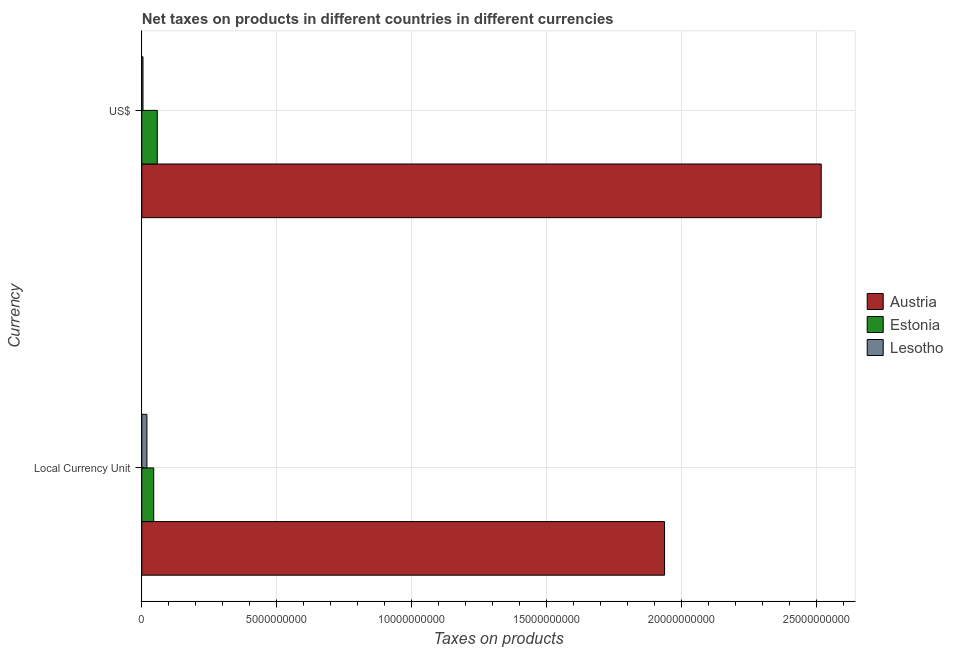How many different coloured bars are there?
Keep it short and to the point. 3. How many groups of bars are there?
Give a very brief answer. 2. Are the number of bars per tick equal to the number of legend labels?
Make the answer very short. Yes. Are the number of bars on each tick of the Y-axis equal?
Your answer should be very brief. Yes. How many bars are there on the 2nd tick from the top?
Make the answer very short. 3. How many bars are there on the 1st tick from the bottom?
Your answer should be compact. 3. What is the label of the 1st group of bars from the top?
Provide a succinct answer. US$. What is the net taxes in constant 2005 us$ in Estonia?
Offer a very short reply. 4.41e+08. Across all countries, what is the maximum net taxes in us$?
Your response must be concise. 2.52e+1. Across all countries, what is the minimum net taxes in constant 2005 us$?
Keep it short and to the point. 1.90e+08. In which country was the net taxes in us$ minimum?
Your answer should be very brief. Lesotho. What is the total net taxes in us$ in the graph?
Ensure brevity in your answer.  2.58e+1. What is the difference between the net taxes in constant 2005 us$ in Austria and that in Lesotho?
Provide a succinct answer. 1.92e+1. What is the difference between the net taxes in constant 2005 us$ in Austria and the net taxes in us$ in Lesotho?
Your answer should be very brief. 1.93e+1. What is the average net taxes in constant 2005 us$ per country?
Offer a very short reply. 6.66e+09. What is the difference between the net taxes in us$ and net taxes in constant 2005 us$ in Estonia?
Your answer should be compact. 1.33e+08. In how many countries, is the net taxes in us$ greater than 17000000000 units?
Give a very brief answer. 1. What is the ratio of the net taxes in us$ in Lesotho to that in Austria?
Provide a short and direct response. 0. Is the net taxes in us$ in Estonia less than that in Lesotho?
Provide a succinct answer. No. In how many countries, is the net taxes in us$ greater than the average net taxes in us$ taken over all countries?
Offer a terse response. 1. What does the 2nd bar from the top in Local Currency Unit represents?
Give a very brief answer. Estonia. How many bars are there?
Your answer should be very brief. 6. Are all the bars in the graph horizontal?
Your response must be concise. Yes. How many countries are there in the graph?
Ensure brevity in your answer.  3. What is the difference between two consecutive major ticks on the X-axis?
Give a very brief answer. 5.00e+09. Are the values on the major ticks of X-axis written in scientific E-notation?
Make the answer very short. No. Does the graph contain grids?
Your response must be concise. Yes. How are the legend labels stacked?
Provide a short and direct response. Vertical. What is the title of the graph?
Make the answer very short. Net taxes on products in different countries in different currencies. What is the label or title of the X-axis?
Offer a very short reply. Taxes on products. What is the label or title of the Y-axis?
Give a very brief answer. Currency. What is the Taxes on products of Austria in Local Currency Unit?
Offer a terse response. 1.94e+1. What is the Taxes on products in Estonia in Local Currency Unit?
Offer a very short reply. 4.41e+08. What is the Taxes on products in Lesotho in Local Currency Unit?
Your answer should be compact. 1.90e+08. What is the Taxes on products in Austria in US$?
Your answer should be compact. 2.52e+1. What is the Taxes on products in Estonia in US$?
Make the answer very short. 5.74e+08. What is the Taxes on products of Lesotho in US$?
Offer a very short reply. 4.42e+07. Across all Currency, what is the maximum Taxes on products in Austria?
Offer a terse response. 2.52e+1. Across all Currency, what is the maximum Taxes on products of Estonia?
Provide a succinct answer. 5.74e+08. Across all Currency, what is the maximum Taxes on products in Lesotho?
Make the answer very short. 1.90e+08. Across all Currency, what is the minimum Taxes on products in Austria?
Your answer should be compact. 1.94e+1. Across all Currency, what is the minimum Taxes on products of Estonia?
Your response must be concise. 4.41e+08. Across all Currency, what is the minimum Taxes on products of Lesotho?
Keep it short and to the point. 4.42e+07. What is the total Taxes on products of Austria in the graph?
Your answer should be very brief. 4.45e+1. What is the total Taxes on products in Estonia in the graph?
Your answer should be compact. 1.02e+09. What is the total Taxes on products of Lesotho in the graph?
Your answer should be very brief. 2.34e+08. What is the difference between the Taxes on products of Austria in Local Currency Unit and that in US$?
Your response must be concise. -5.80e+09. What is the difference between the Taxes on products in Estonia in Local Currency Unit and that in US$?
Your response must be concise. -1.33e+08. What is the difference between the Taxes on products of Lesotho in Local Currency Unit and that in US$?
Give a very brief answer. 1.46e+08. What is the difference between the Taxes on products in Austria in Local Currency Unit and the Taxes on products in Estonia in US$?
Your answer should be very brief. 1.88e+1. What is the difference between the Taxes on products of Austria in Local Currency Unit and the Taxes on products of Lesotho in US$?
Make the answer very short. 1.93e+1. What is the difference between the Taxes on products of Estonia in Local Currency Unit and the Taxes on products of Lesotho in US$?
Offer a terse response. 3.97e+08. What is the average Taxes on products in Austria per Currency?
Provide a short and direct response. 2.23e+1. What is the average Taxes on products in Estonia per Currency?
Your answer should be very brief. 5.08e+08. What is the average Taxes on products in Lesotho per Currency?
Provide a short and direct response. 1.17e+08. What is the difference between the Taxes on products of Austria and Taxes on products of Estonia in Local Currency Unit?
Your answer should be very brief. 1.89e+1. What is the difference between the Taxes on products of Austria and Taxes on products of Lesotho in Local Currency Unit?
Ensure brevity in your answer.  1.92e+1. What is the difference between the Taxes on products of Estonia and Taxes on products of Lesotho in Local Currency Unit?
Your response must be concise. 2.51e+08. What is the difference between the Taxes on products in Austria and Taxes on products in Estonia in US$?
Offer a terse response. 2.46e+1. What is the difference between the Taxes on products of Austria and Taxes on products of Lesotho in US$?
Your answer should be very brief. 2.51e+1. What is the difference between the Taxes on products of Estonia and Taxes on products of Lesotho in US$?
Make the answer very short. 5.30e+08. What is the ratio of the Taxes on products in Austria in Local Currency Unit to that in US$?
Provide a succinct answer. 0.77. What is the ratio of the Taxes on products in Estonia in Local Currency Unit to that in US$?
Ensure brevity in your answer.  0.77. What is the ratio of the Taxes on products of Lesotho in Local Currency Unit to that in US$?
Provide a short and direct response. 4.3. What is the difference between the highest and the second highest Taxes on products in Austria?
Make the answer very short. 5.80e+09. What is the difference between the highest and the second highest Taxes on products of Estonia?
Your answer should be very brief. 1.33e+08. What is the difference between the highest and the second highest Taxes on products of Lesotho?
Offer a very short reply. 1.46e+08. What is the difference between the highest and the lowest Taxes on products of Austria?
Your answer should be compact. 5.80e+09. What is the difference between the highest and the lowest Taxes on products of Estonia?
Your answer should be very brief. 1.33e+08. What is the difference between the highest and the lowest Taxes on products in Lesotho?
Make the answer very short. 1.46e+08. 